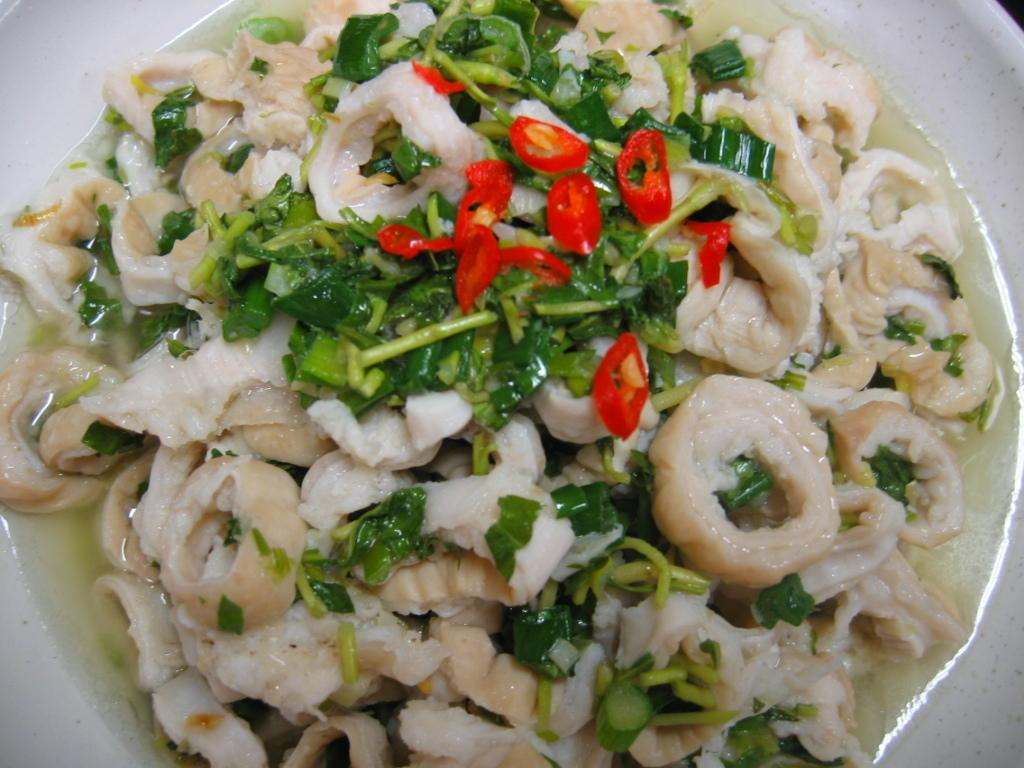What type of bowl is featured in the image? There is a prince bowl in the image. What is inside the prince bowl? The prince bowl contains salad. Is there a ship transporting the soup in the image? There is no ship or soup present in the image; it features a prince bowl containing salad. 